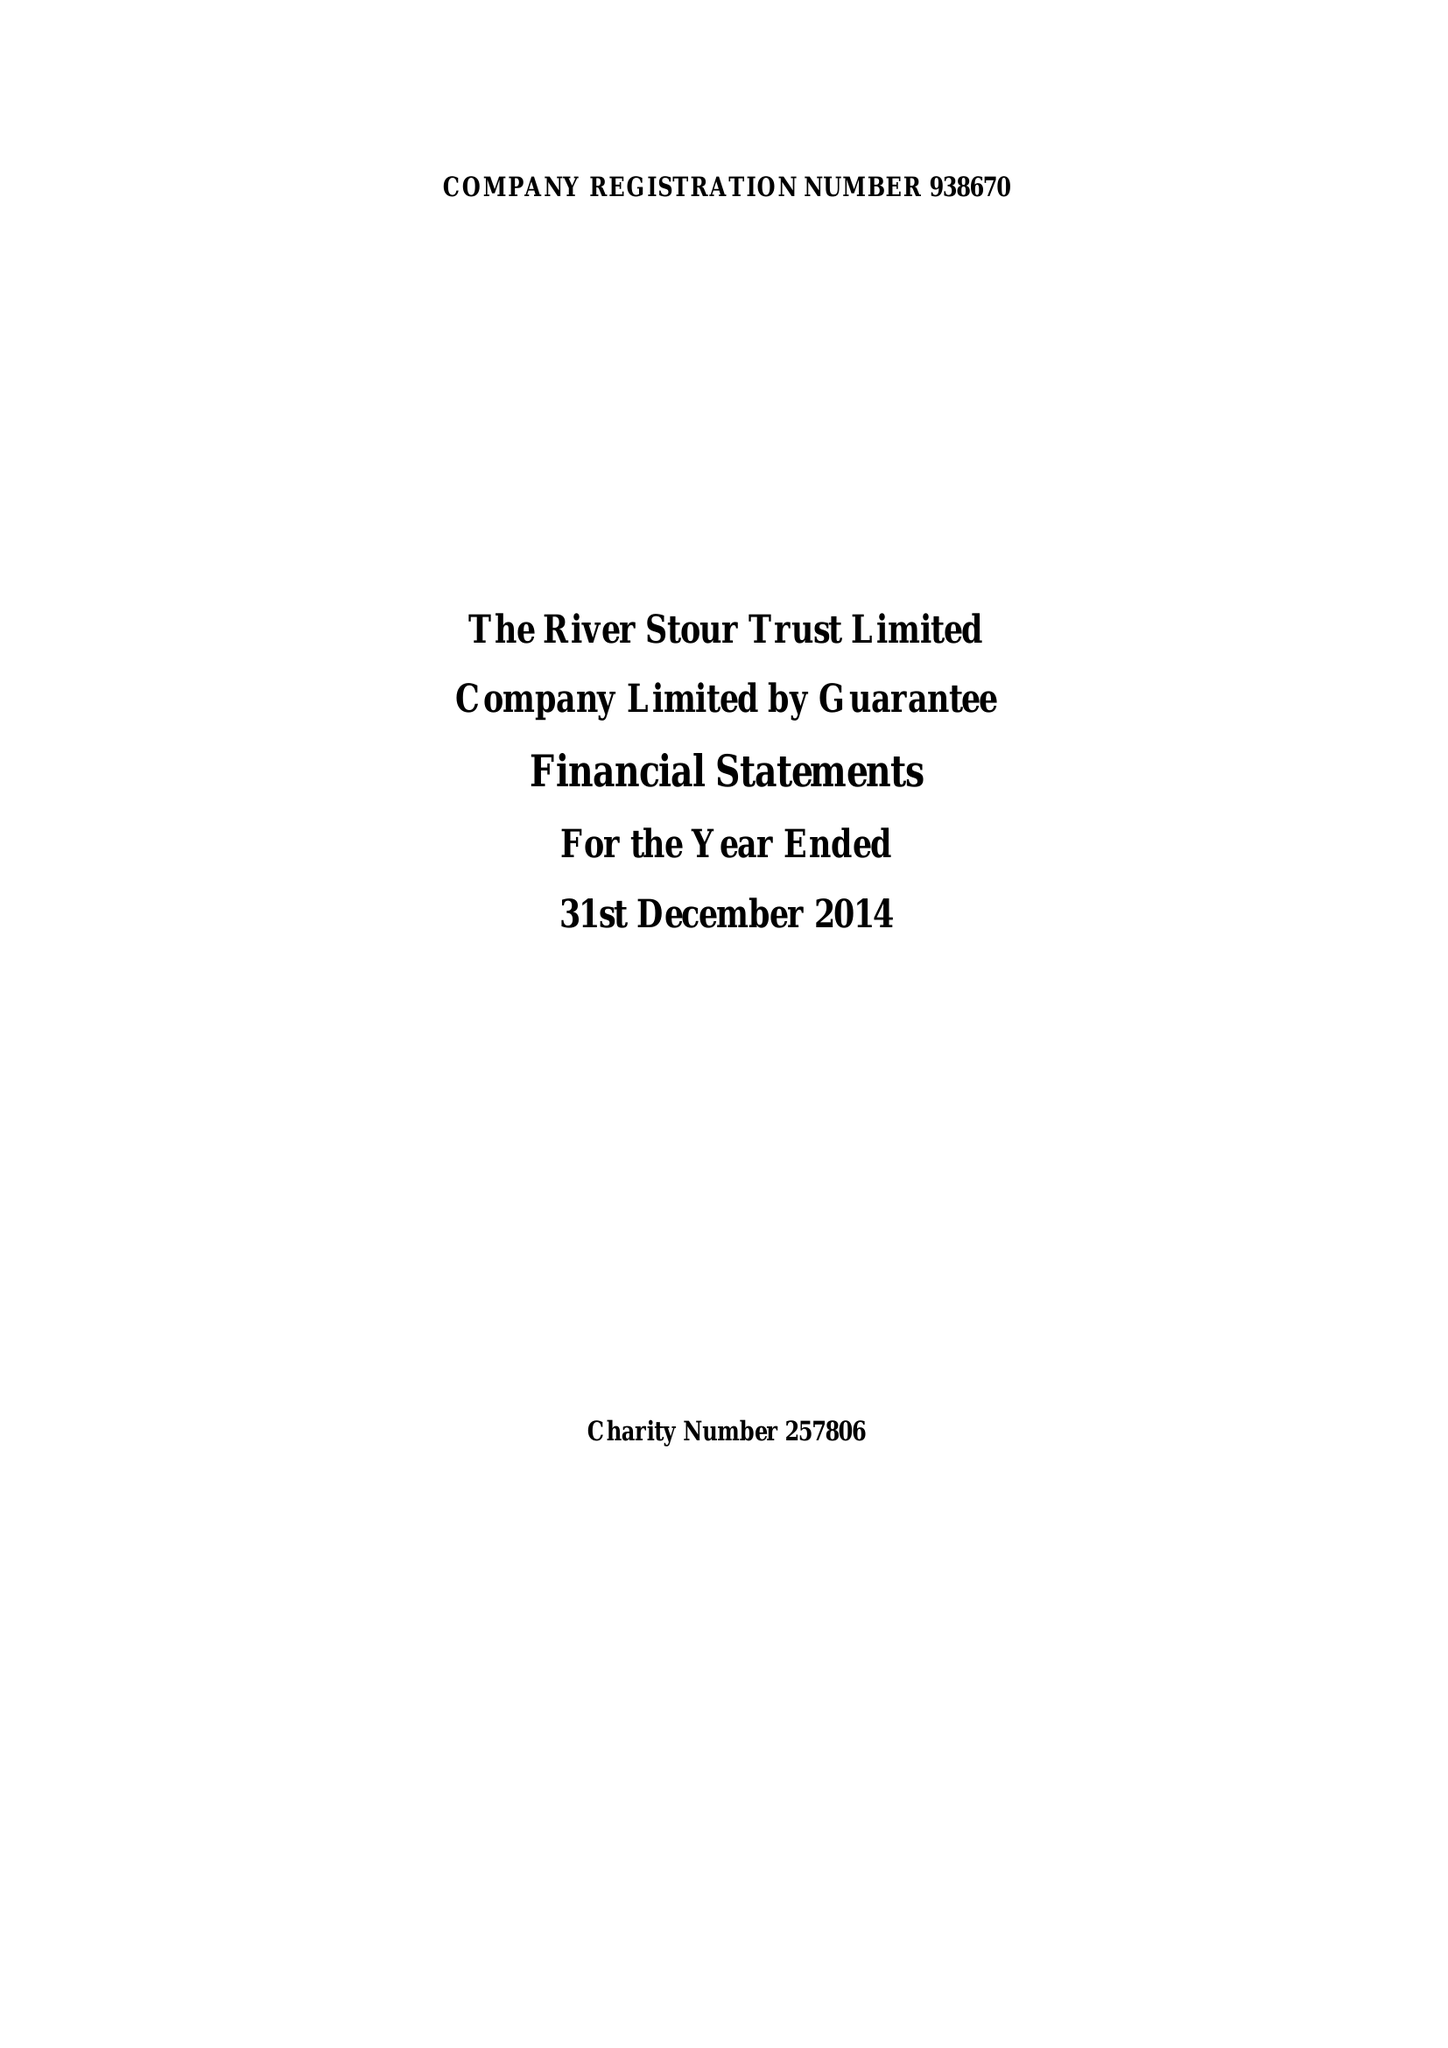What is the value for the income_annually_in_british_pounds?
Answer the question using a single word or phrase. 158665.00 